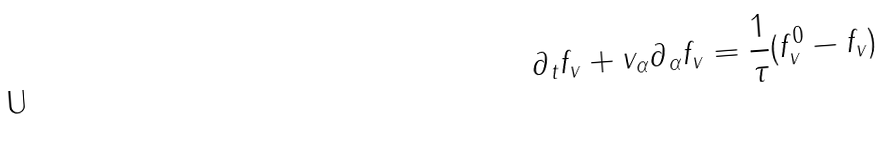<formula> <loc_0><loc_0><loc_500><loc_500>\partial _ { t } f _ { v } + v _ { \alpha } \partial _ { \alpha } f _ { v } = \frac { 1 } { \tau } ( f ^ { 0 } _ { v } - f _ { v } )</formula> 